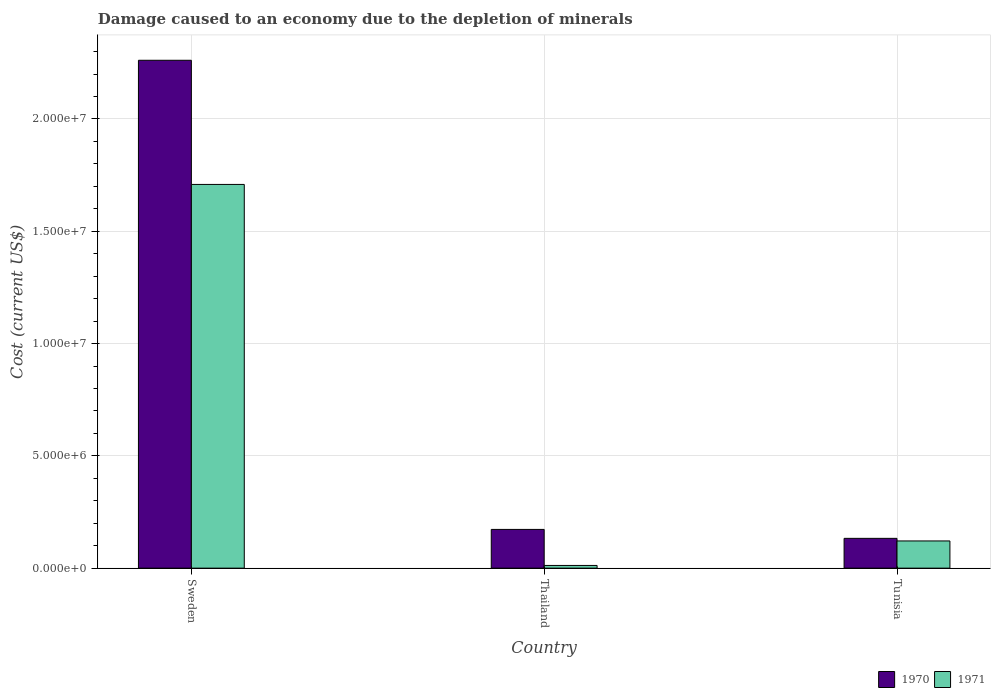How many different coloured bars are there?
Your answer should be compact. 2. How many groups of bars are there?
Give a very brief answer. 3. How many bars are there on the 3rd tick from the right?
Offer a very short reply. 2. What is the label of the 3rd group of bars from the left?
Keep it short and to the point. Tunisia. What is the cost of damage caused due to the depletion of minerals in 1971 in Tunisia?
Provide a succinct answer. 1.21e+06. Across all countries, what is the maximum cost of damage caused due to the depletion of minerals in 1970?
Your response must be concise. 2.26e+07. Across all countries, what is the minimum cost of damage caused due to the depletion of minerals in 1970?
Your answer should be compact. 1.33e+06. In which country was the cost of damage caused due to the depletion of minerals in 1970 maximum?
Offer a very short reply. Sweden. In which country was the cost of damage caused due to the depletion of minerals in 1971 minimum?
Provide a short and direct response. Thailand. What is the total cost of damage caused due to the depletion of minerals in 1971 in the graph?
Ensure brevity in your answer.  1.84e+07. What is the difference between the cost of damage caused due to the depletion of minerals in 1971 in Sweden and that in Tunisia?
Offer a terse response. 1.59e+07. What is the difference between the cost of damage caused due to the depletion of minerals in 1971 in Sweden and the cost of damage caused due to the depletion of minerals in 1970 in Thailand?
Offer a very short reply. 1.54e+07. What is the average cost of damage caused due to the depletion of minerals in 1970 per country?
Make the answer very short. 8.55e+06. What is the difference between the cost of damage caused due to the depletion of minerals of/in 1971 and cost of damage caused due to the depletion of minerals of/in 1970 in Thailand?
Provide a succinct answer. -1.60e+06. In how many countries, is the cost of damage caused due to the depletion of minerals in 1971 greater than 11000000 US$?
Offer a very short reply. 1. What is the ratio of the cost of damage caused due to the depletion of minerals in 1970 in Sweden to that in Thailand?
Make the answer very short. 13.11. Is the cost of damage caused due to the depletion of minerals in 1971 in Thailand less than that in Tunisia?
Your response must be concise. Yes. What is the difference between the highest and the second highest cost of damage caused due to the depletion of minerals in 1971?
Your answer should be very brief. -1.70e+07. What is the difference between the highest and the lowest cost of damage caused due to the depletion of minerals in 1971?
Provide a short and direct response. 1.70e+07. Is the sum of the cost of damage caused due to the depletion of minerals in 1970 in Sweden and Thailand greater than the maximum cost of damage caused due to the depletion of minerals in 1971 across all countries?
Provide a short and direct response. Yes. How many countries are there in the graph?
Your answer should be compact. 3. Are the values on the major ticks of Y-axis written in scientific E-notation?
Your answer should be very brief. Yes. Does the graph contain any zero values?
Offer a very short reply. No. Where does the legend appear in the graph?
Ensure brevity in your answer.  Bottom right. How are the legend labels stacked?
Ensure brevity in your answer.  Horizontal. What is the title of the graph?
Keep it short and to the point. Damage caused to an economy due to the depletion of minerals. Does "1968" appear as one of the legend labels in the graph?
Offer a terse response. No. What is the label or title of the Y-axis?
Make the answer very short. Cost (current US$). What is the Cost (current US$) of 1970 in Sweden?
Your response must be concise. 2.26e+07. What is the Cost (current US$) in 1971 in Sweden?
Give a very brief answer. 1.71e+07. What is the Cost (current US$) of 1970 in Thailand?
Your answer should be very brief. 1.72e+06. What is the Cost (current US$) of 1971 in Thailand?
Provide a succinct answer. 1.21e+05. What is the Cost (current US$) of 1970 in Tunisia?
Offer a very short reply. 1.33e+06. What is the Cost (current US$) in 1971 in Tunisia?
Offer a very short reply. 1.21e+06. Across all countries, what is the maximum Cost (current US$) in 1970?
Keep it short and to the point. 2.26e+07. Across all countries, what is the maximum Cost (current US$) of 1971?
Provide a succinct answer. 1.71e+07. Across all countries, what is the minimum Cost (current US$) of 1970?
Offer a terse response. 1.33e+06. Across all countries, what is the minimum Cost (current US$) of 1971?
Provide a short and direct response. 1.21e+05. What is the total Cost (current US$) of 1970 in the graph?
Make the answer very short. 2.57e+07. What is the total Cost (current US$) of 1971 in the graph?
Your response must be concise. 1.84e+07. What is the difference between the Cost (current US$) in 1970 in Sweden and that in Thailand?
Ensure brevity in your answer.  2.09e+07. What is the difference between the Cost (current US$) of 1971 in Sweden and that in Thailand?
Keep it short and to the point. 1.70e+07. What is the difference between the Cost (current US$) of 1970 in Sweden and that in Tunisia?
Your answer should be compact. 2.13e+07. What is the difference between the Cost (current US$) in 1971 in Sweden and that in Tunisia?
Give a very brief answer. 1.59e+07. What is the difference between the Cost (current US$) of 1970 in Thailand and that in Tunisia?
Your answer should be compact. 3.98e+05. What is the difference between the Cost (current US$) in 1971 in Thailand and that in Tunisia?
Make the answer very short. -1.09e+06. What is the difference between the Cost (current US$) in 1970 in Sweden and the Cost (current US$) in 1971 in Thailand?
Your answer should be compact. 2.25e+07. What is the difference between the Cost (current US$) in 1970 in Sweden and the Cost (current US$) in 1971 in Tunisia?
Provide a short and direct response. 2.14e+07. What is the difference between the Cost (current US$) of 1970 in Thailand and the Cost (current US$) of 1971 in Tunisia?
Your response must be concise. 5.13e+05. What is the average Cost (current US$) in 1970 per country?
Offer a very short reply. 8.55e+06. What is the average Cost (current US$) in 1971 per country?
Your answer should be compact. 6.14e+06. What is the difference between the Cost (current US$) in 1970 and Cost (current US$) in 1971 in Sweden?
Provide a succinct answer. 5.53e+06. What is the difference between the Cost (current US$) in 1970 and Cost (current US$) in 1971 in Thailand?
Make the answer very short. 1.60e+06. What is the difference between the Cost (current US$) of 1970 and Cost (current US$) of 1971 in Tunisia?
Offer a terse response. 1.16e+05. What is the ratio of the Cost (current US$) in 1970 in Sweden to that in Thailand?
Keep it short and to the point. 13.11. What is the ratio of the Cost (current US$) in 1971 in Sweden to that in Thailand?
Your answer should be compact. 141.73. What is the ratio of the Cost (current US$) in 1970 in Sweden to that in Tunisia?
Offer a very short reply. 17.04. What is the ratio of the Cost (current US$) of 1971 in Sweden to that in Tunisia?
Provide a short and direct response. 14.1. What is the ratio of the Cost (current US$) of 1970 in Thailand to that in Tunisia?
Provide a short and direct response. 1.3. What is the ratio of the Cost (current US$) of 1971 in Thailand to that in Tunisia?
Provide a short and direct response. 0.1. What is the difference between the highest and the second highest Cost (current US$) in 1970?
Your answer should be very brief. 2.09e+07. What is the difference between the highest and the second highest Cost (current US$) of 1971?
Make the answer very short. 1.59e+07. What is the difference between the highest and the lowest Cost (current US$) of 1970?
Provide a succinct answer. 2.13e+07. What is the difference between the highest and the lowest Cost (current US$) of 1971?
Give a very brief answer. 1.70e+07. 